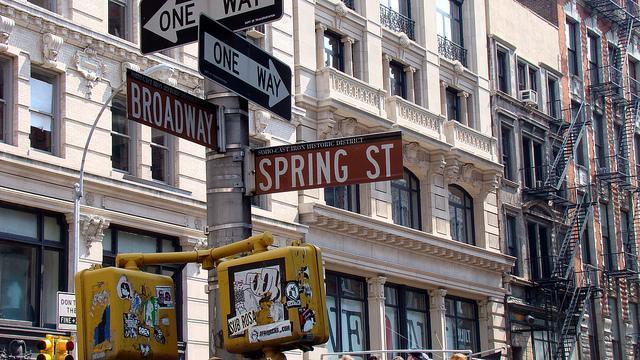How many signs are there?
Give a very brief answer. 4. How many Brown Street signs do you see?
Give a very brief answer. 2. How many traffic lights are in the picture?
Give a very brief answer. 2. 